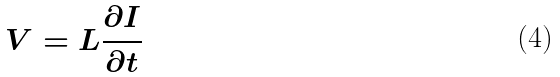<formula> <loc_0><loc_0><loc_500><loc_500>V = L \frac { \partial I } { \partial t }</formula> 